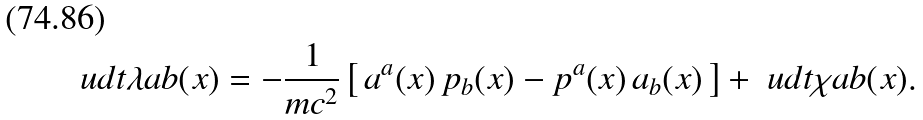<formula> <loc_0><loc_0><loc_500><loc_500>\ u d t { \lambda } { a } { b } ( x ) = - \frac { 1 } { m c ^ { 2 } } \left [ \, a ^ { a } ( x ) \, p _ { b } ( x ) - p ^ { a } ( x ) \, a _ { b } ( x ) \, \right ] + \ u d t { \chi } { a } { b } ( x ) .</formula> 